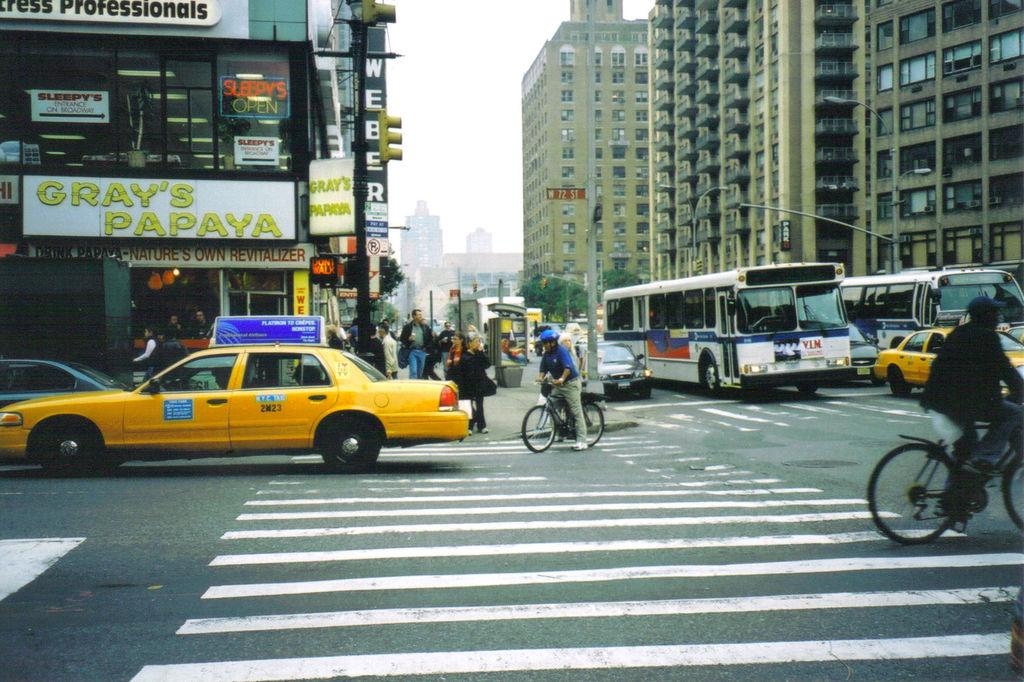<image>
Write a terse but informative summary of the picture. a taxi is in front of gray's papaya 